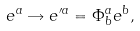<formula> <loc_0><loc_0><loc_500><loc_500>e ^ { a } \rightarrow e ^ { \prime a } = \Phi ^ { a } _ { b } e ^ { b } ,</formula> 